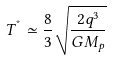<formula> <loc_0><loc_0><loc_500><loc_500>T ^ { ^ { * } } \simeq \frac { 8 } { 3 } \sqrt { \frac { 2 q ^ { 3 } } { G M _ { p } } }</formula> 